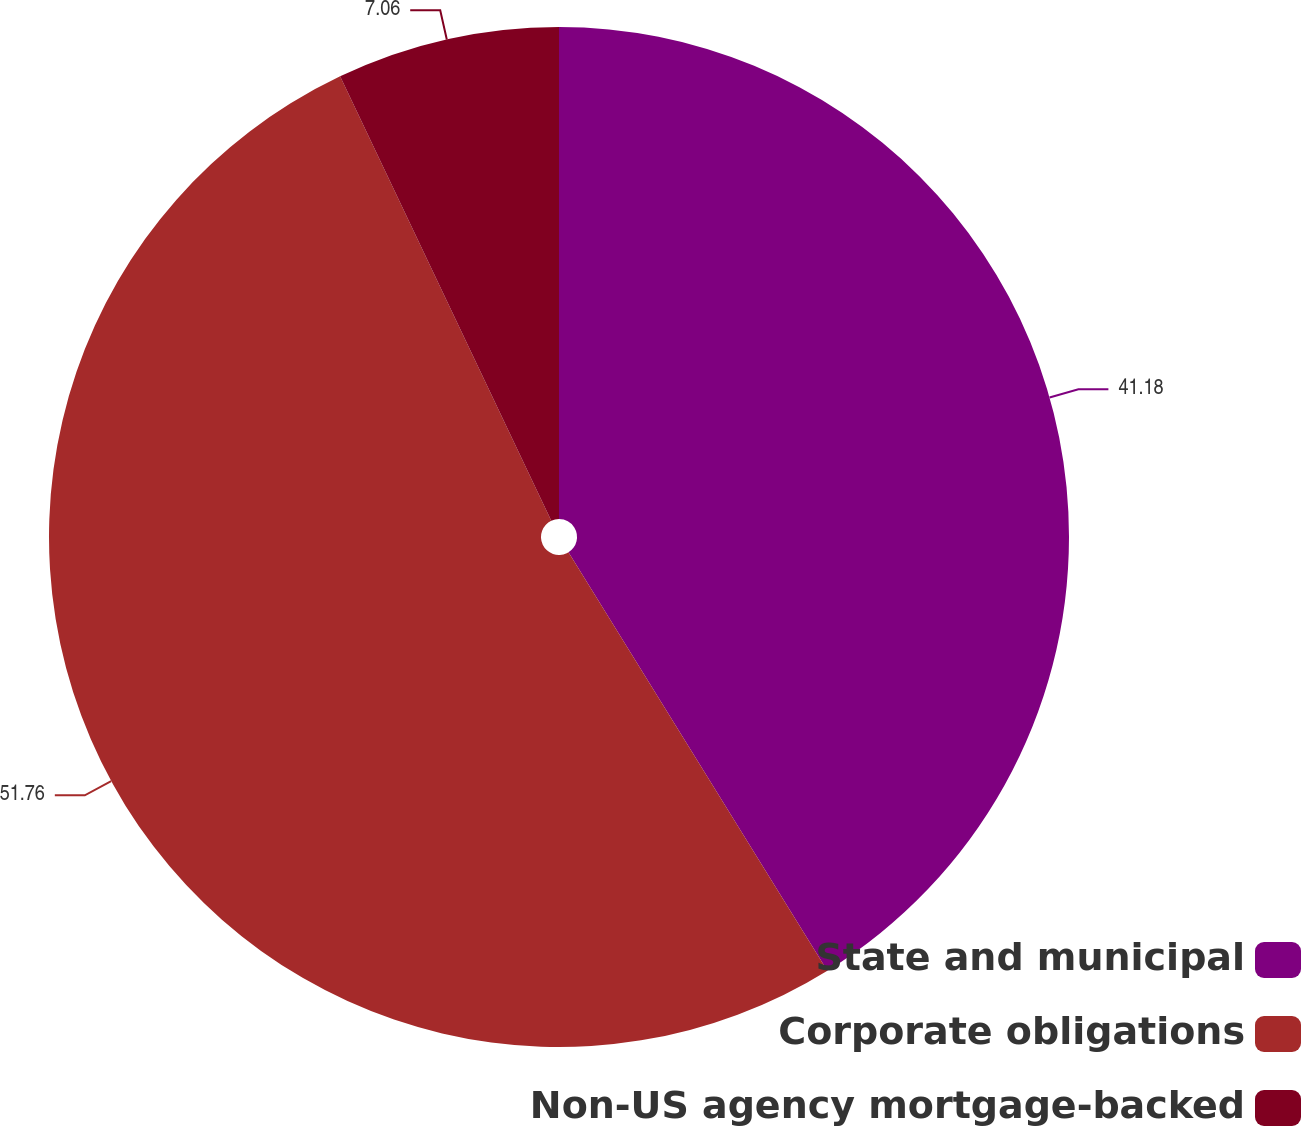<chart> <loc_0><loc_0><loc_500><loc_500><pie_chart><fcel>State and municipal<fcel>Corporate obligations<fcel>Non-US agency mortgage-backed<nl><fcel>41.18%<fcel>51.76%<fcel>7.06%<nl></chart> 